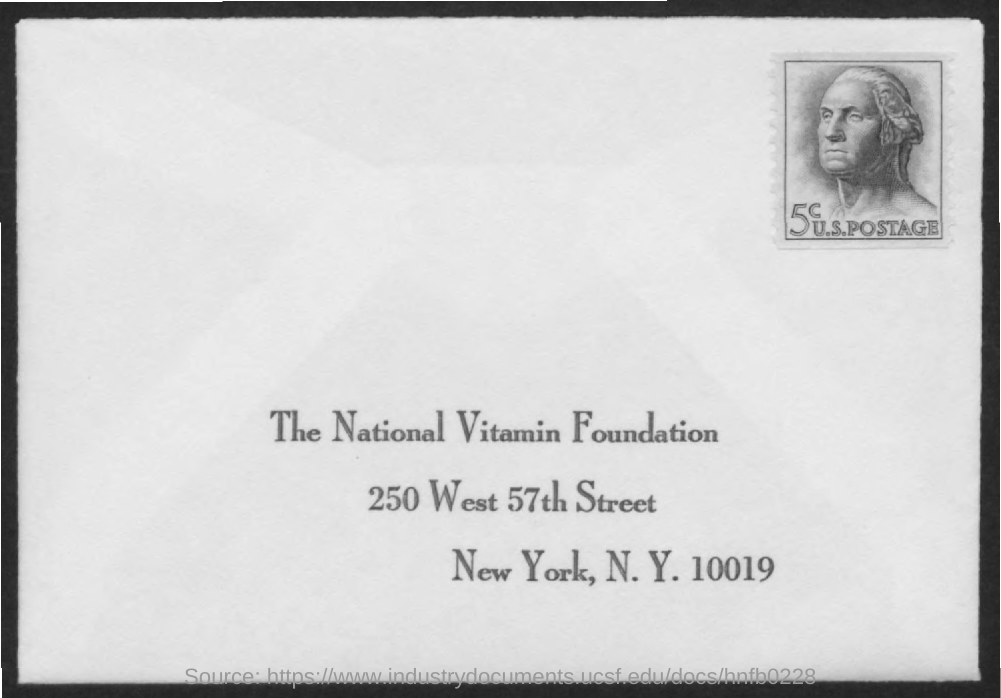What is the title of the document?
Your response must be concise. The National Vitamin Foundation. 